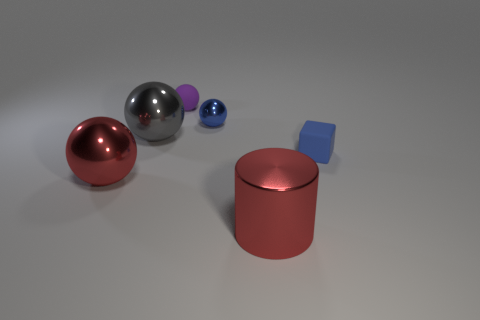Subtract all tiny blue shiny balls. How many balls are left? 3 Subtract all blue balls. How many balls are left? 3 Add 3 gray spheres. How many objects exist? 9 Subtract all red spheres. Subtract all yellow cylinders. How many spheres are left? 3 Subtract all spheres. How many objects are left? 2 Add 5 red cylinders. How many red cylinders are left? 6 Add 6 blocks. How many blocks exist? 7 Subtract 0 brown cubes. How many objects are left? 6 Subtract all balls. Subtract all blue shiny objects. How many objects are left? 1 